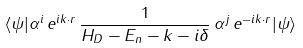<formula> <loc_0><loc_0><loc_500><loc_500>\langle { \psi } | \alpha ^ { i } \, e ^ { i { k } \cdot { r } } \, \frac { 1 } { H _ { D } - E _ { n } - k - i \delta } \, \alpha ^ { j } \, e ^ { - i { k } \cdot { r } } | \psi \rangle</formula> 